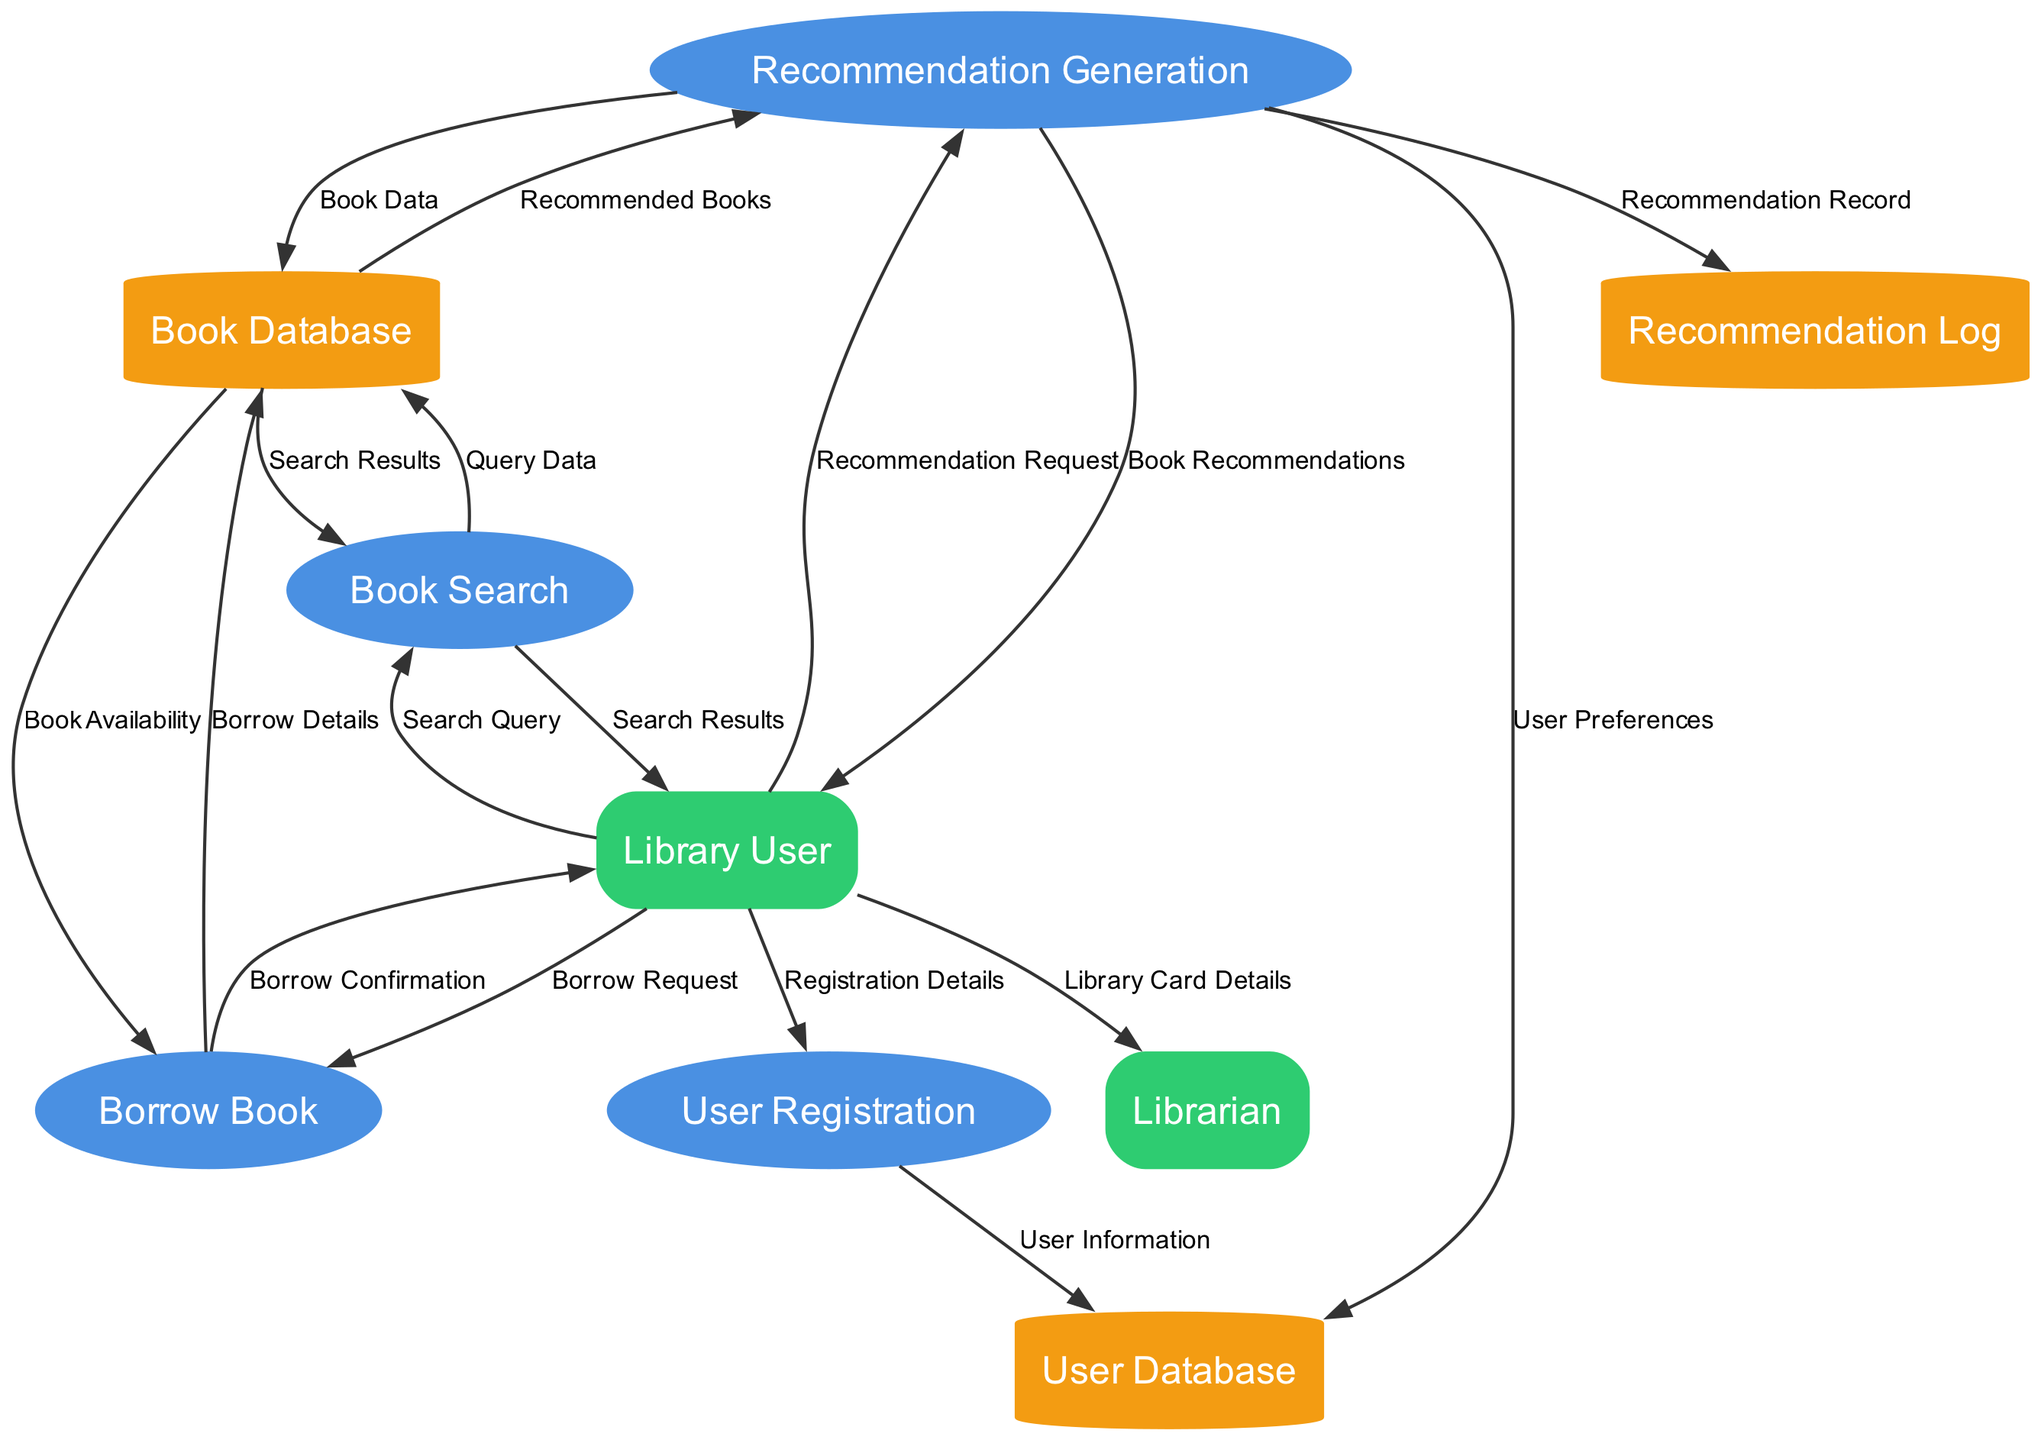What is the total number of processes in the diagram? There are four processes listed in the diagram: User Registration, Book Search, Recommendation Generation, and Borrow Book. Counting these processes gives a total of four.
Answer: 4 Which entity provides the Registration Details? The data flow originating from the Library User indicates that they provide the Registration Details when registering.
Answer: Library User What type of information is stored in the User Database? The data flow from User Registration to User Database shows that User Information is stored in the User Database. This includes the data individuals provide during their registration.
Answer: User Information What action occurs after a Library User makes a Borrow Request? The flow from Library User to Borrow Book describes that once the Borrow Request is submitted, the Borrow Book process interacts with the Book Database to check for Book Availability. This is the immediate action that follows.
Answer: Book Availability How many data flows link Recommendation Generation to other components? Recommendation Generation connects to three components: Book Database, User Database, and Recommendation Log. Each of these interactions involves a flow of different types of data related to recommendations. Counting these yields a total of three data flows from Recommendation Generation.
Answer: 3 Which two processes interact with the Book Database? The Book Search and Borrow Book are the two processes that send and receive data to/from the Book Database. Book Search queries it for search results, and Borrow Book checks for book availability before confirming a borrow.
Answer: Book Search and Borrow Book What is the primary data that flows from Recommendation Generation to Library User? The data flow from Recommendation Generation to Library User indicates that the Book Recommendations are sent to the Library User, providing them with a list tailored to their request.
Answer: Book Recommendations What is the purpose of the Recommendation Log in the system? The Recommendation Log is intended to store the Recommendation Record generated by the Recommendation Generation process. This allows tracking and possibly analyzing previous recommendations for improving future suggestions.
Answer: Recommendation Record Which external entity interacts with the Librarian? The flow of Library Card Details originates from the Library User and directly goes to the Librarian, indicating that the user communicates their library details to the librarian when necessary.
Answer: Library User 